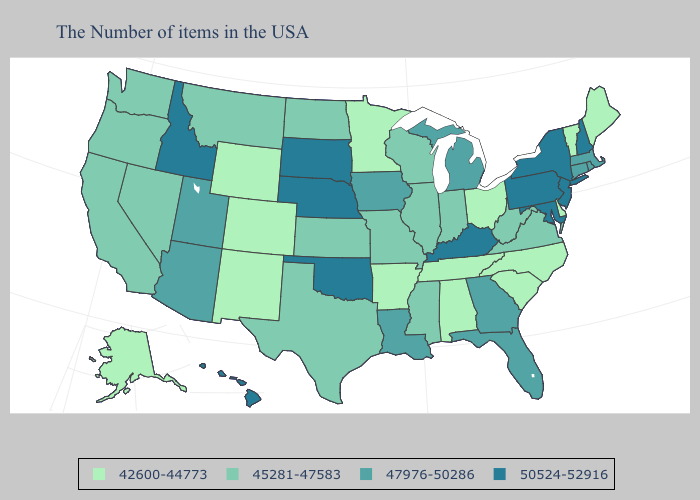Does Kansas have the same value as Indiana?
Quick response, please. Yes. Among the states that border Kentucky , does Ohio have the highest value?
Answer briefly. No. What is the lowest value in states that border Washington?
Give a very brief answer. 45281-47583. Name the states that have a value in the range 47976-50286?
Write a very short answer. Massachusetts, Rhode Island, Connecticut, Florida, Georgia, Michigan, Louisiana, Iowa, Utah, Arizona. Name the states that have a value in the range 45281-47583?
Answer briefly. Virginia, West Virginia, Indiana, Wisconsin, Illinois, Mississippi, Missouri, Kansas, Texas, North Dakota, Montana, Nevada, California, Washington, Oregon. What is the value of Illinois?
Answer briefly. 45281-47583. Does Tennessee have a lower value than California?
Quick response, please. Yes. Name the states that have a value in the range 42600-44773?
Concise answer only. Maine, Vermont, Delaware, North Carolina, South Carolina, Ohio, Alabama, Tennessee, Arkansas, Minnesota, Wyoming, Colorado, New Mexico, Alaska. Among the states that border Washington , does Idaho have the lowest value?
Answer briefly. No. Name the states that have a value in the range 50524-52916?
Write a very short answer. New Hampshire, New York, New Jersey, Maryland, Pennsylvania, Kentucky, Nebraska, Oklahoma, South Dakota, Idaho, Hawaii. What is the value of North Carolina?
Write a very short answer. 42600-44773. Name the states that have a value in the range 42600-44773?
Answer briefly. Maine, Vermont, Delaware, North Carolina, South Carolina, Ohio, Alabama, Tennessee, Arkansas, Minnesota, Wyoming, Colorado, New Mexico, Alaska. Does Iowa have a higher value than Alaska?
Short answer required. Yes. Which states have the lowest value in the West?
Short answer required. Wyoming, Colorado, New Mexico, Alaska. Name the states that have a value in the range 42600-44773?
Concise answer only. Maine, Vermont, Delaware, North Carolina, South Carolina, Ohio, Alabama, Tennessee, Arkansas, Minnesota, Wyoming, Colorado, New Mexico, Alaska. 